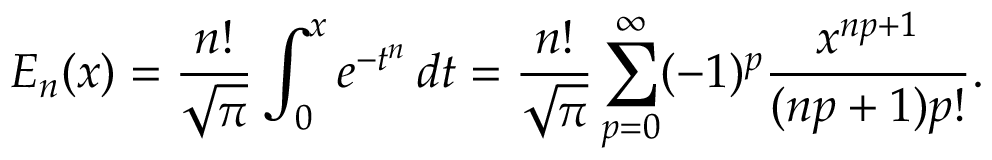<formula> <loc_0><loc_0><loc_500><loc_500>E _ { n } ( x ) = { \frac { n ! } { \sqrt { \pi } } } \int _ { 0 } ^ { x } e ^ { - t ^ { n } } \, d t = { \frac { n ! } { \sqrt { \pi } } } \sum _ { p = 0 } ^ { \infty } ( - 1 ) ^ { p } { \frac { x ^ { n p + 1 } } { ( n p + 1 ) p ! } } .</formula> 